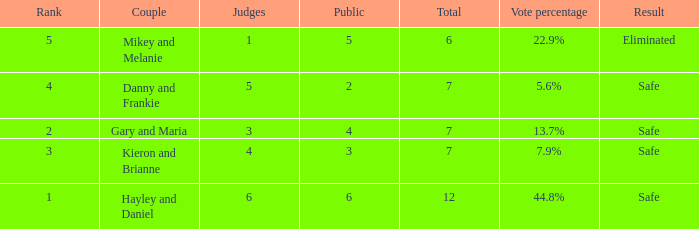What is the number of public that was there when the vote percentage was 22.9%? 1.0. 